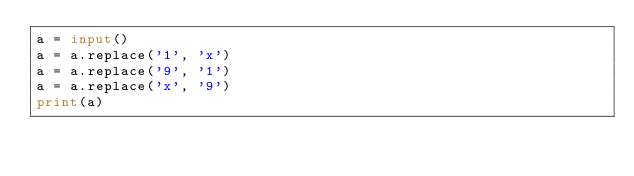<code> <loc_0><loc_0><loc_500><loc_500><_Python_>a = input()
a = a.replace('1', 'x')
a = a.replace('9', '1')
a = a.replace('x', '9')
print(a)</code> 